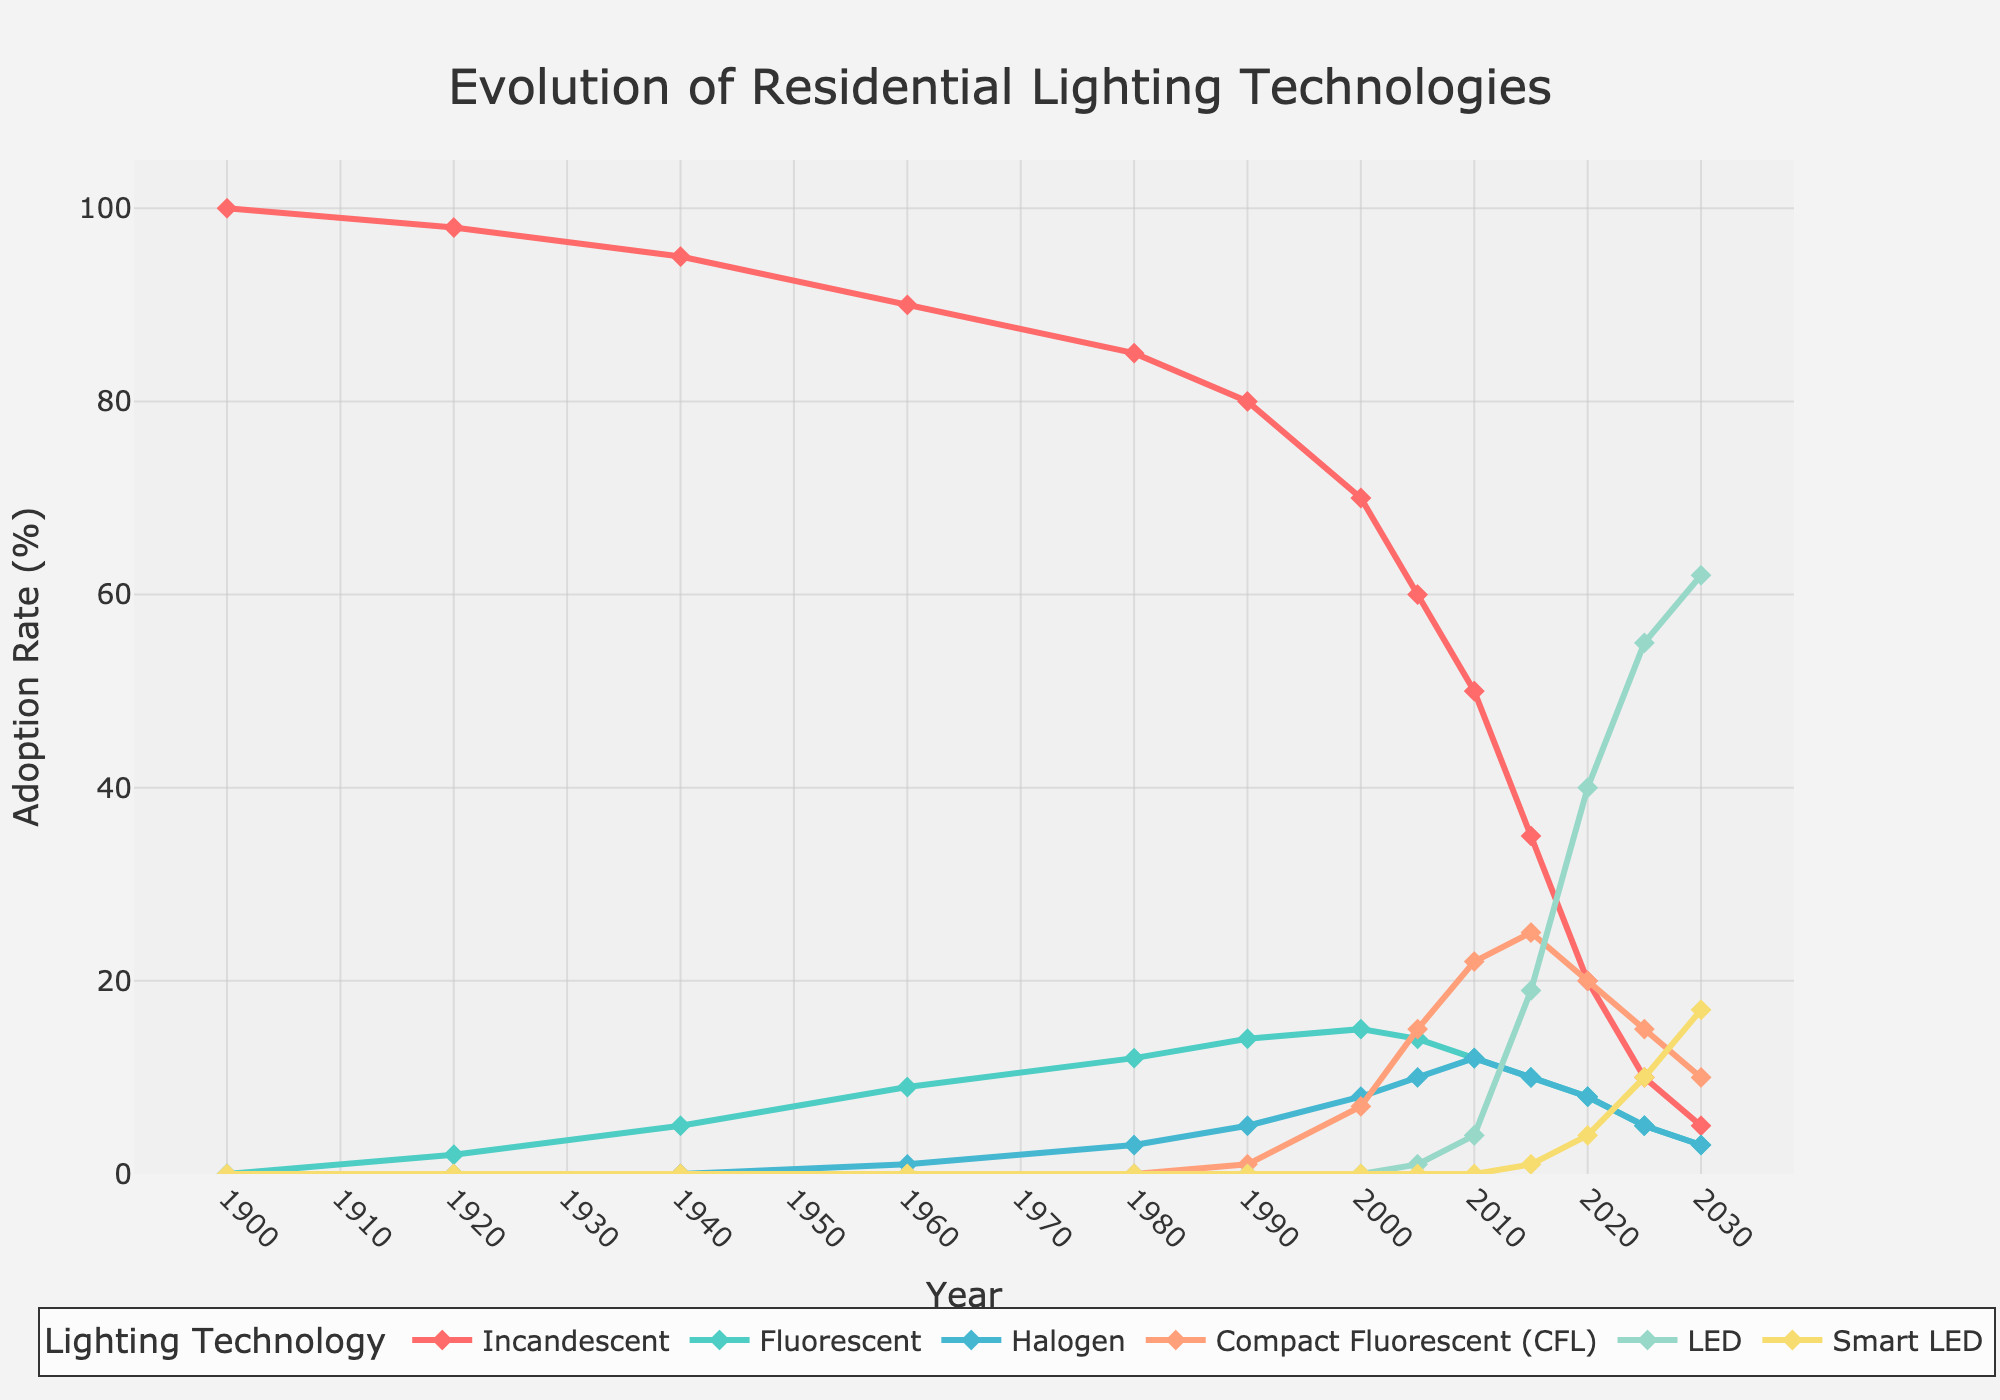What trends are visible for incandescent lighting over the years? Incandescent lighting shows a steady decline from 100% in 1900 to 5% in 2030. It was the dominant technology initially but gradually declined as newer technologies emerged and gained popularity.
Answer: Steady decline In which year does LED lighting surpass Compact Fluorescent (CFL) adoption? From the figure, LED adoption surpasses CFL around 2020, where LEDs are at 40% and CFLs are at 20%.
Answer: 2020 What is the combined adoption rate of Halogen and Smart LED technologies in 2025? In 2025, Halogen adoption is at 5% and Smart LED is at 10%. The combined adoption rate is 5 + 10.
Answer: 15% Which year shows the highest adoption rate for Compact Fluorescent (CFL) lighting? The highest adoption rate for CFL is around 2015, where its adoption rate is approximately 25%.
Answer: 2015 How does the adoption rate of Fluorescent lighting change from 1980 to 2020? Fluorescent lighting adoption increases from 12% in 1980 to 8% in 2020. Therefore, it generally peaks around 1990 and then gradually declines.
Answer: Peaks in 1990, then declines Compare the adoption rates of LED and Smart LED lighting in 2030. In 2030, the adoption rate for LED is 62%, while Smart LED is 17%. Thus, LED adoption is much higher than Smart LED.
Answer: LED: 62%, Smart LED: 17% Among all the technologies shown, which has the most significant gain in adoption rate from 2000 to 2025? From 2000 to 2025, LED shows the most significant gain, increasing from 0% in 2000 to 55% in 2025.
Answer: LED Which technology has the least fluctuation in adoption rate over the period shown? Fluorescent lighting shows the least fluctuation as it moves gradually between 0% to around 15% without any major peaks or dips.
Answer: Fluorescent By 2030, what is the adoption rate gap between the oldest (Incandescent) and newest technology (Smart LED)? In 2030, Incandescent is at 5% and Smart LED is at 17%. The gap is 17 - 5.
Answer: 12% 